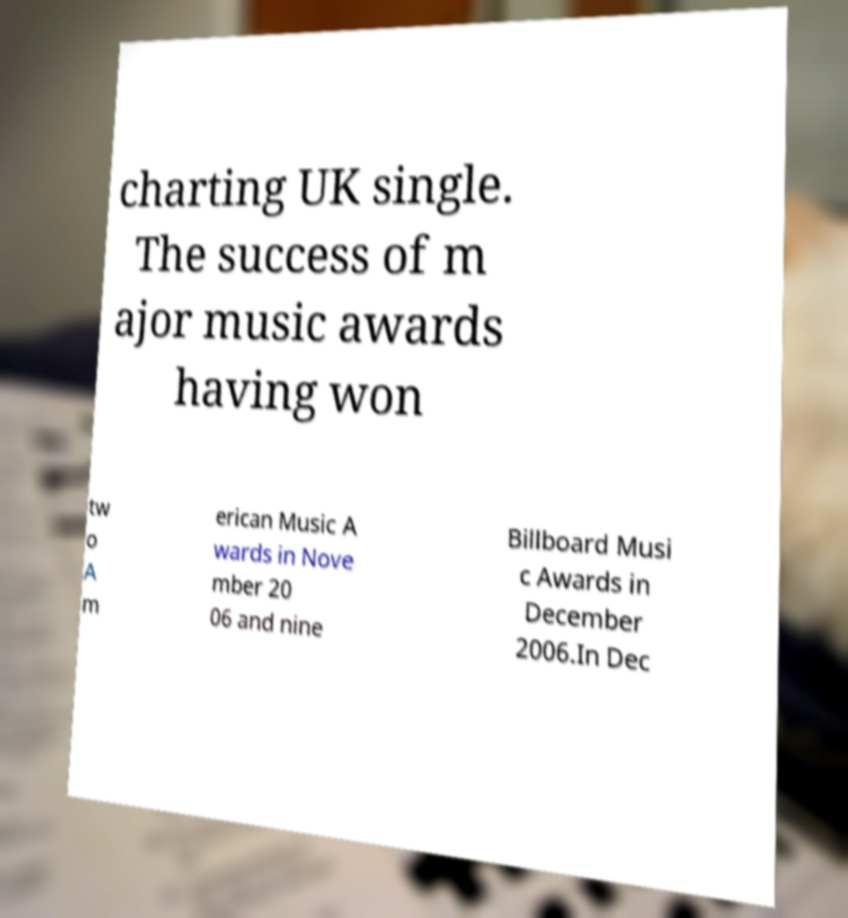Could you extract and type out the text from this image? charting UK single. The success of m ajor music awards having won tw o A m erican Music A wards in Nove mber 20 06 and nine Billboard Musi c Awards in December 2006.In Dec 